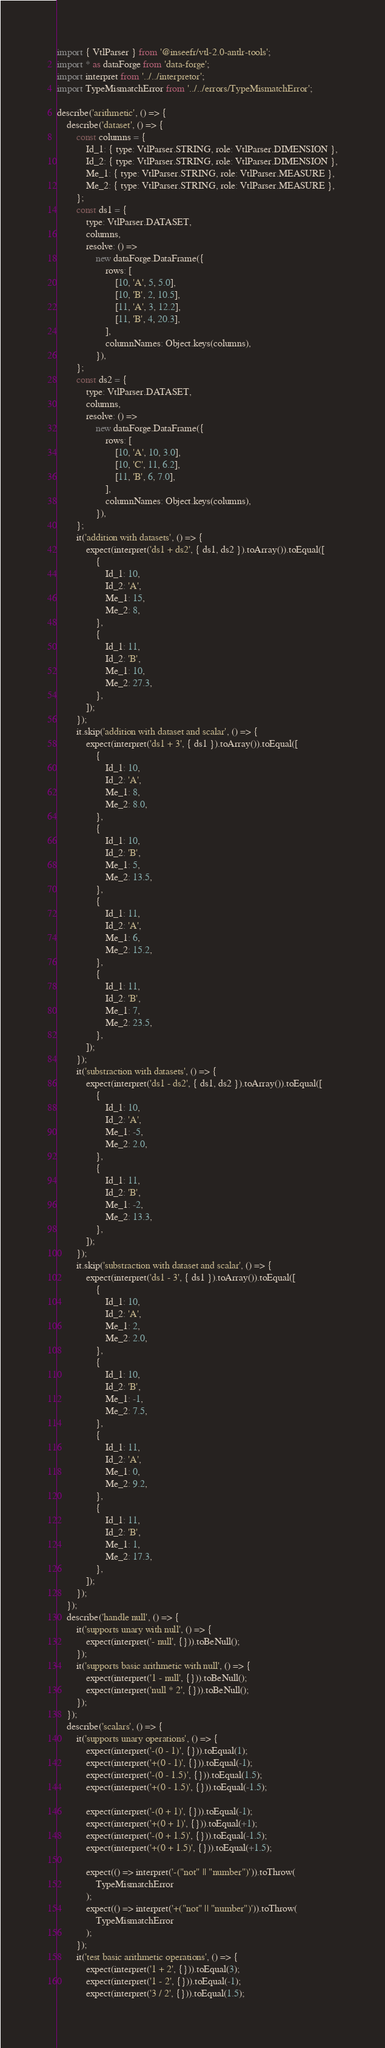Convert code to text. <code><loc_0><loc_0><loc_500><loc_500><_JavaScript_>import { VtlParser } from '@inseefr/vtl-2.0-antlr-tools';
import * as dataForge from 'data-forge';
import interpret from '../../interpretor';
import TypeMismatchError from '../../errors/TypeMismatchError';

describe('arithmetic', () => {
	describe('dataset', () => {
		const columns = {
			Id_1: { type: VtlParser.STRING, role: VtlParser.DIMENSION },
			Id_2: { type: VtlParser.STRING, role: VtlParser.DIMENSION },
			Me_1: { type: VtlParser.STRING, role: VtlParser.MEASURE },
			Me_2: { type: VtlParser.STRING, role: VtlParser.MEASURE },
		};
		const ds1 = {
			type: VtlParser.DATASET,
			columns,
			resolve: () =>
				new dataForge.DataFrame({
					rows: [
						[10, 'A', 5, 5.0],
						[10, 'B', 2, 10.5],
						[11, 'A', 3, 12.2],
						[11, 'B', 4, 20.3],
					],
					columnNames: Object.keys(columns),
				}),
		};
		const ds2 = {
			type: VtlParser.DATASET,
			columns,
			resolve: () =>
				new dataForge.DataFrame({
					rows: [
						[10, 'A', 10, 3.0],
						[10, 'C', 11, 6.2],
						[11, 'B', 6, 7.0],
					],
					columnNames: Object.keys(columns),
				}),
		};
		it('addition with datasets', () => {
			expect(interpret('ds1 + ds2', { ds1, ds2 }).toArray()).toEqual([
				{
					Id_1: 10,
					Id_2: 'A',
					Me_1: 15,
					Me_2: 8,
				},
				{
					Id_1: 11,
					Id_2: 'B',
					Me_1: 10,
					Me_2: 27.3,
				},
			]);
		});
		it.skip('addition with dataset and scalar', () => {
			expect(interpret('ds1 + 3', { ds1 }).toArray()).toEqual([
				{
					Id_1: 10,
					Id_2: 'A',
					Me_1: 8,
					Me_2: 8.0,
				},
				{
					Id_1: 10,
					Id_2: 'B',
					Me_1: 5,
					Me_2: 13.5,
				},
				{
					Id_1: 11,
					Id_2: 'A',
					Me_1: 6,
					Me_2: 15.2,
				},
				{
					Id_1: 11,
					Id_2: 'B',
					Me_1: 7,
					Me_2: 23.5,
				},
			]);
		});
		it('substraction with datasets', () => {
			expect(interpret('ds1 - ds2', { ds1, ds2 }).toArray()).toEqual([
				{
					Id_1: 10,
					Id_2: 'A',
					Me_1: -5,
					Me_2: 2.0,
				},
				{
					Id_1: 11,
					Id_2: 'B',
					Me_1: -2,
					Me_2: 13.3,
				},
			]);
		});
		it.skip('substraction with dataset and scalar', () => {
			expect(interpret('ds1 - 3', { ds1 }).toArray()).toEqual([
				{
					Id_1: 10,
					Id_2: 'A',
					Me_1: 2,
					Me_2: 2.0,
				},
				{
					Id_1: 10,
					Id_2: 'B',
					Me_1: -1,
					Me_2: 7.5,
				},
				{
					Id_1: 11,
					Id_2: 'A',
					Me_1: 0,
					Me_2: 9.2,
				},
				{
					Id_1: 11,
					Id_2: 'B',
					Me_1: 1,
					Me_2: 17.3,
				},
			]);
		});
	});
	describe('handle null', () => {
		it('supports unary with null', () => {
			expect(interpret('- null', {})).toBeNull();
		});
		it('supports basic arithmetic with null', () => {
			expect(interpret('1 - null', {})).toBeNull();
			expect(interpret('null * 2', {})).toBeNull();
		});
	});
	describe('scalars', () => {
		it('supports unary operations', () => {
			expect(interpret('-(0 - 1)', {})).toEqual(1);
			expect(interpret('+(0 - 1)', {})).toEqual(-1);
			expect(interpret('-(0 - 1.5)', {})).toEqual(1.5);
			expect(interpret('+(0 - 1.5)', {})).toEqual(-1.5);

			expect(interpret('-(0 + 1)', {})).toEqual(-1);
			expect(interpret('+(0 + 1)', {})).toEqual(+1);
			expect(interpret('-(0 + 1.5)', {})).toEqual(-1.5);
			expect(interpret('+(0 + 1.5)', {})).toEqual(+1.5);

			expect(() => interpret('-("not" || "number")')).toThrow(
				TypeMismatchError
			);
			expect(() => interpret('+("not" || "number")')).toThrow(
				TypeMismatchError
			);
		});
		it('test basic arithmetic operations', () => {
			expect(interpret('1 + 2', {})).toEqual(3);
			expect(interpret('1 - 2', {})).toEqual(-1);
			expect(interpret('3 / 2', {})).toEqual(1.5);</code> 